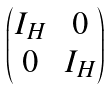<formula> <loc_0><loc_0><loc_500><loc_500>\begin{pmatrix} I _ { H } & 0 \\ 0 & I _ { H } \end{pmatrix}</formula> 